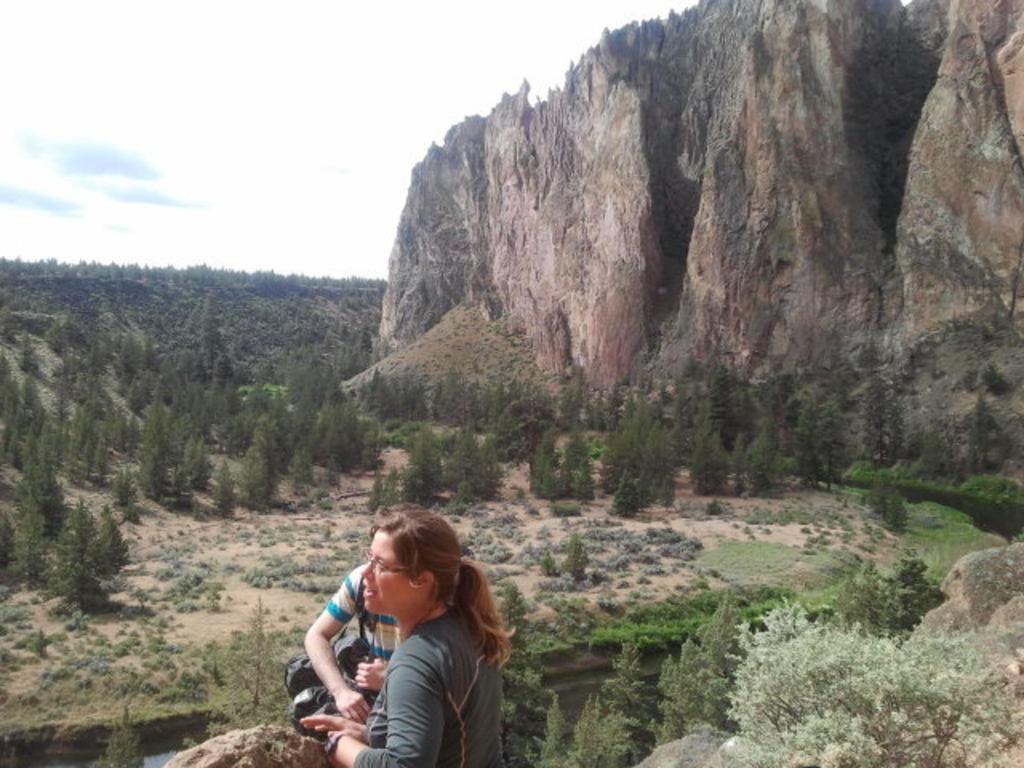How would you summarize this image in a sentence or two? In this picture there is a woman who is wearing spectacle, t-shirt and watch. Beside her there is a man who is wearing t-shirt and holding a bag. Both of them are standing near to the stones and plants. In the back I can see many trees, plants, grass and river. On the right I can see the stone mountains. In the top left I can see the sky and clouds. 